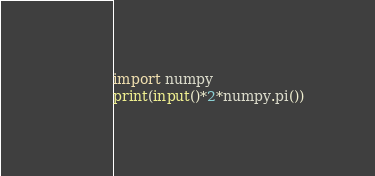<code> <loc_0><loc_0><loc_500><loc_500><_Python_>import numpy
print(input()*2*numpy.pi())</code> 